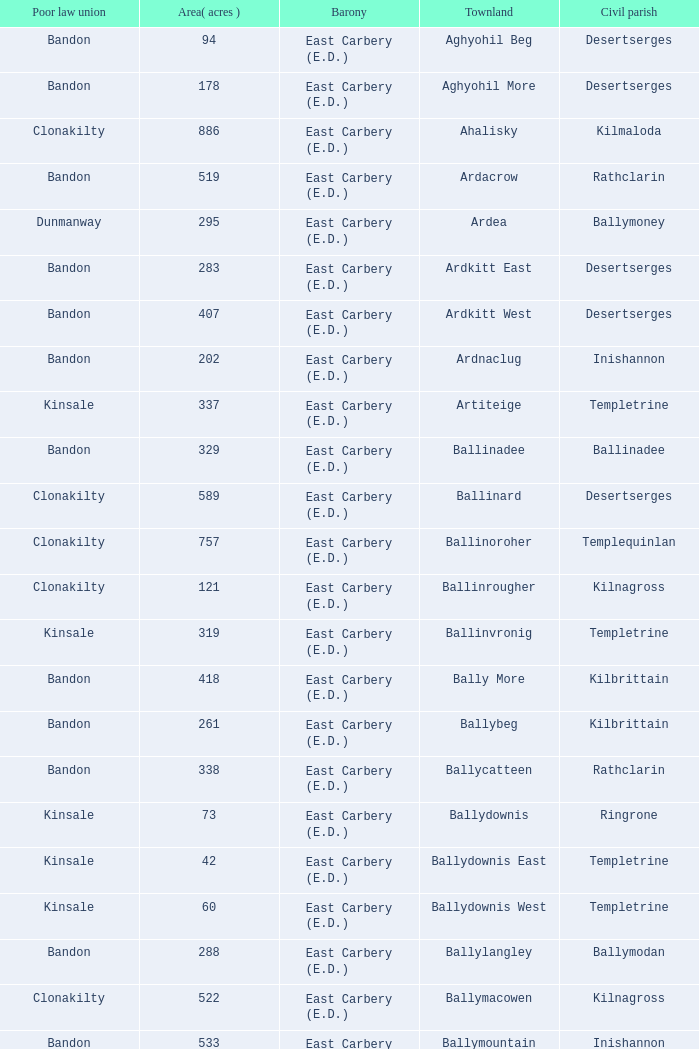What is the maximum area (in acres) of the Knockacullen townland? 381.0. 